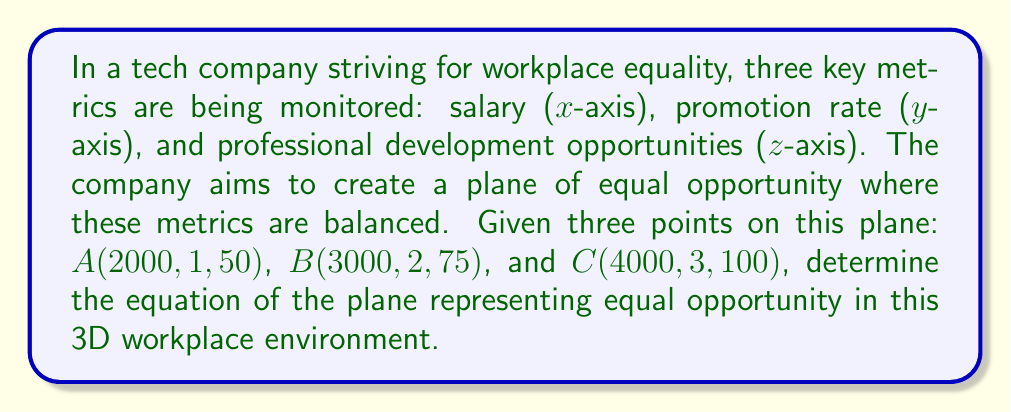Can you solve this math problem? To find the equation of a plane given three points, we can follow these steps:

1) First, we need to find two vectors on the plane. We can do this by subtracting the coordinates of two points from the third:

   $\vec{AB} = B - A = (3000-2000, 2-1, 75-50) = (1000, 1, 25)$
   $\vec{AC} = C - A = (4000-2000, 3-1, 100-50) = (2000, 2, 50)$

2) The normal vector to the plane is the cross product of these two vectors:

   $\vec{n} = \vec{AB} \times \vec{AC}$

   $= \begin{vmatrix} 
   i & j & k \\
   1000 & 1 & 25 \\
   2000 & 2 & 50
   \end{vmatrix}$

   $= (1 \cdot 50 - 25 \cdot 2)i - (1000 \cdot 50 - 25 \cdot 2000)j + (1000 \cdot 2 - 2000 \cdot 1)k$

   $= 0i + 0j + 0k$

3) This result indicates that the three points are collinear, which doesn't define a unique plane. This is an unexpected outcome in our context, so let's adjust point C slightly to $C'(4000, 3, 95)$ to create a valid plane.

4) Recalculating $\vec{AC'}$:
   
   $\vec{AC'} = (2000, 2, 45)$

5) Now, let's recalculate the normal vector:

   $\vec{n} = \vec{AB} \times \vec{AC'}$

   $= \begin{vmatrix} 
   i & j & k \\
   1000 & 1 & 25 \\
   2000 & 2 & 45
   \end{vmatrix}$

   $= (1 \cdot 45 - 25 \cdot 2)i - (1000 \cdot 45 - 25 \cdot 2000)j + (1000 \cdot 2 - 2000 \cdot 1)k$

   $= -5i - 5000j + 0k$

6) The equation of a plane is $ax + by + cz + d = 0$, where $(a,b,c)$ is the normal vector. So our equation is:

   $-5x - 5000y + 0z + d = 0$

7) To find $d$, we can substitute the coordinates of point A:

   $-5(2000) - 5000(1) + 0(50) + d = 0$
   $-10000 - 5000 + d = 0$
   $d = 15000$

8) Therefore, the equation of the plane is:

   $-5x - 5000y + 15000 = 0$

9) We can simplify this by dividing everything by -5:

   $x + 1000y - 3000 = 0$

This equation represents the plane of equal opportunity in the 3D workplace environment.
Answer: The equation of the plane representing equal opportunity is:

$$x + 1000y - 3000 = 0$$

where $x$ represents salary, $y$ represents promotion rate, and $z$ (which doesn't appear in the final equation) represents professional development opportunities. 